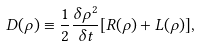Convert formula to latex. <formula><loc_0><loc_0><loc_500><loc_500>D ( \rho ) \equiv \frac { 1 } { 2 } \frac { \delta \rho ^ { 2 } } { \delta t } [ R ( \rho ) + L ( \rho ) ] ,</formula> 